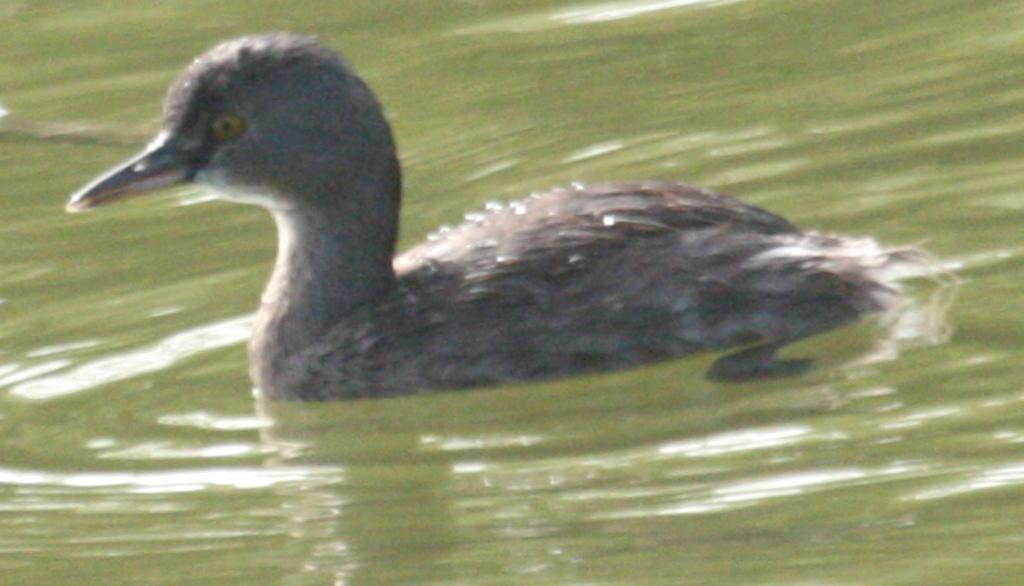What is the main subject of the image? There is a duck in the center of the image. What can be seen in the background of the image? There is water present in the background of the image. What type of toothpaste is the duck using in the image? There is no toothpaste present in the image, and ducks do not use toothpaste. What kind of apparatus is the duck operating in the image? There is no apparatus present in the image, and ducks do not operate machinery. 